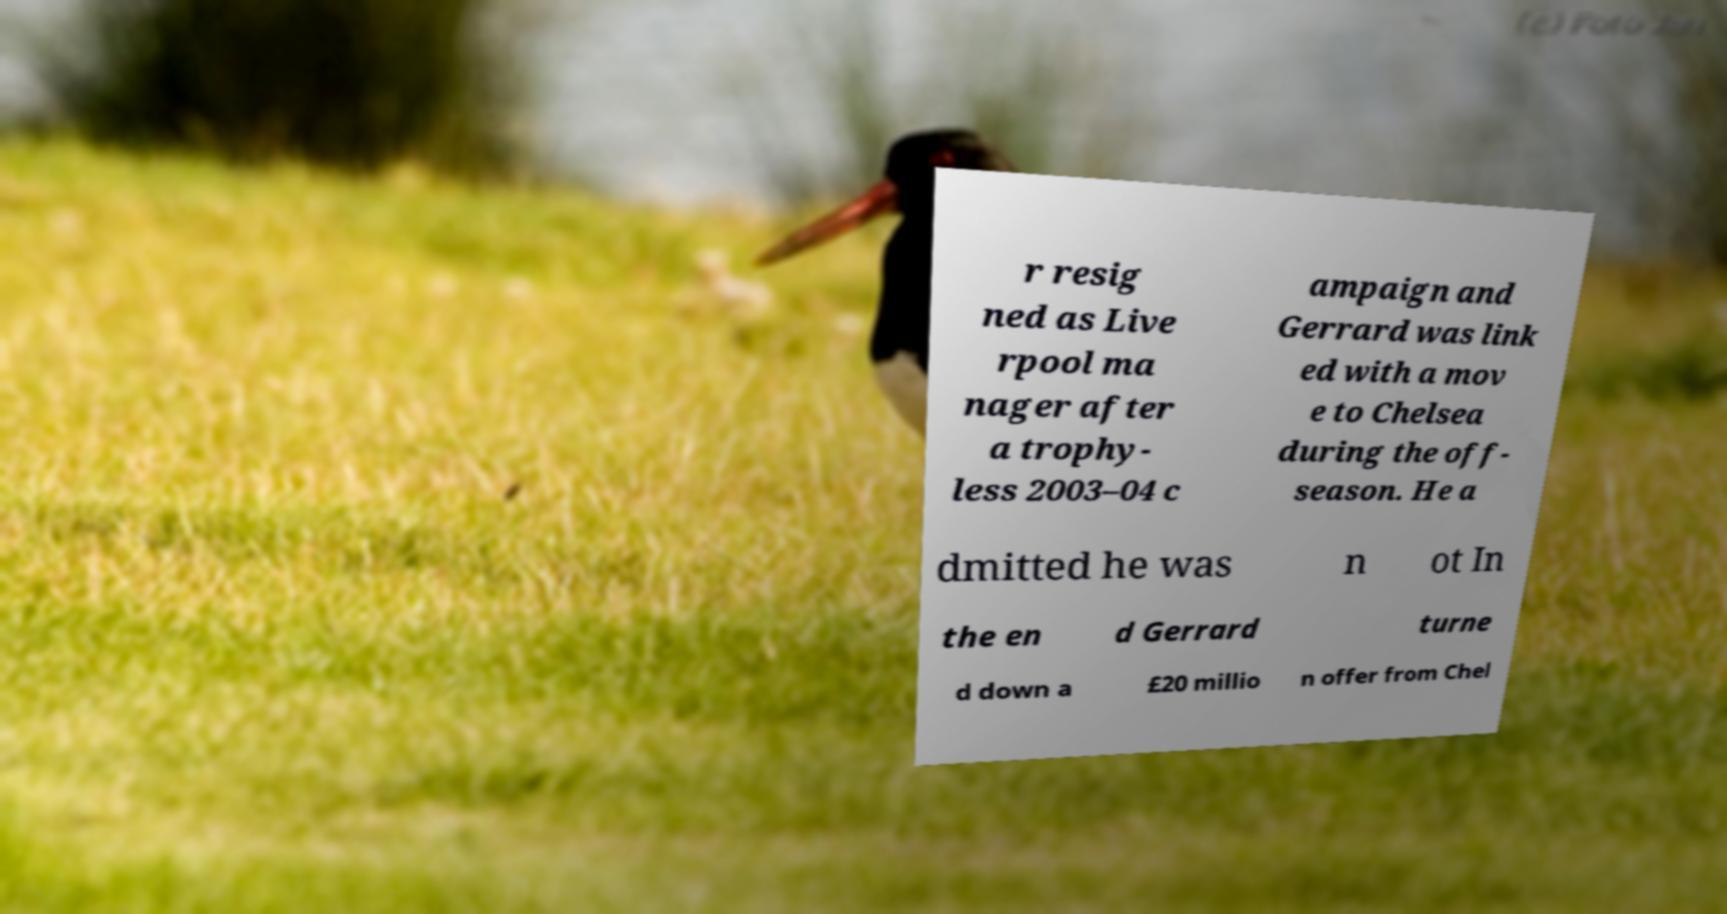Please read and relay the text visible in this image. What does it say? r resig ned as Live rpool ma nager after a trophy- less 2003–04 c ampaign and Gerrard was link ed with a mov e to Chelsea during the off- season. He a dmitted he was n ot In the en d Gerrard turne d down a £20 millio n offer from Chel 